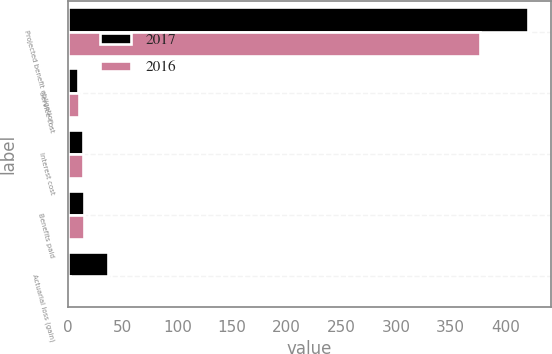<chart> <loc_0><loc_0><loc_500><loc_500><stacked_bar_chart><ecel><fcel>Projected benefit obligation -<fcel>Service cost<fcel>Interest cost<fcel>Benefits paid<fcel>Actuarial loss (gain)<nl><fcel>2017<fcel>420.7<fcel>8.7<fcel>14<fcel>14.9<fcel>36.9<nl><fcel>2016<fcel>376.9<fcel>9.6<fcel>13.8<fcel>14.3<fcel>1.6<nl></chart> 